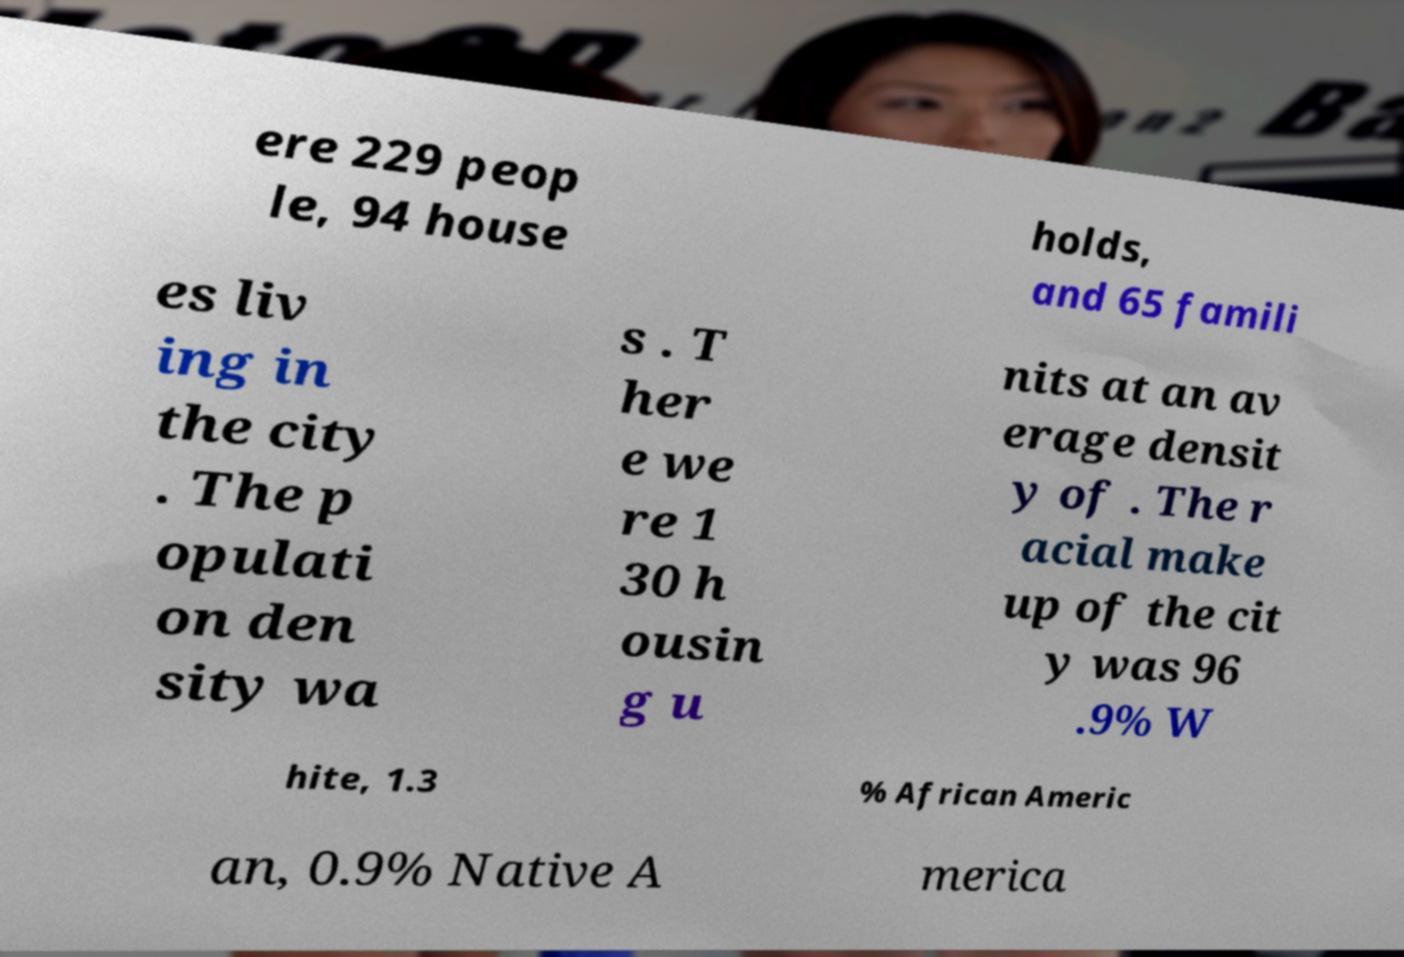Please read and relay the text visible in this image. What does it say? ere 229 peop le, 94 house holds, and 65 famili es liv ing in the city . The p opulati on den sity wa s . T her e we re 1 30 h ousin g u nits at an av erage densit y of . The r acial make up of the cit y was 96 .9% W hite, 1.3 % African Americ an, 0.9% Native A merica 